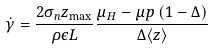<formula> <loc_0><loc_0><loc_500><loc_500>\dot { \gamma } = \frac { 2 \sigma _ { n } z _ { \max } } { \rho \epsilon L } \frac { \mu _ { H } - \mu p \left ( 1 - \Delta \right ) } { \Delta \langle z \rangle }</formula> 